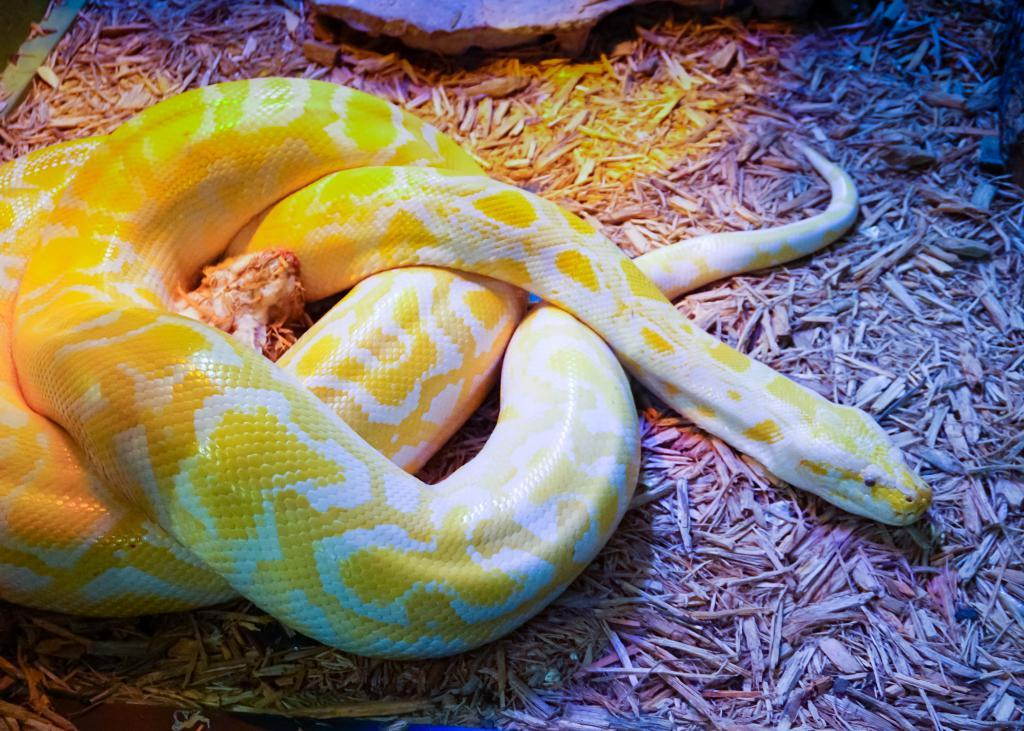What animal is present in the image? There is a snake in the image. Where is the snake located? The snake is on the ground. What object is near the snake? There is a stone beside the snake. What type of ink is the laborer using to reward the snake in the image? There is no laborer or ink present in the image, and the snake is not being rewarded. 